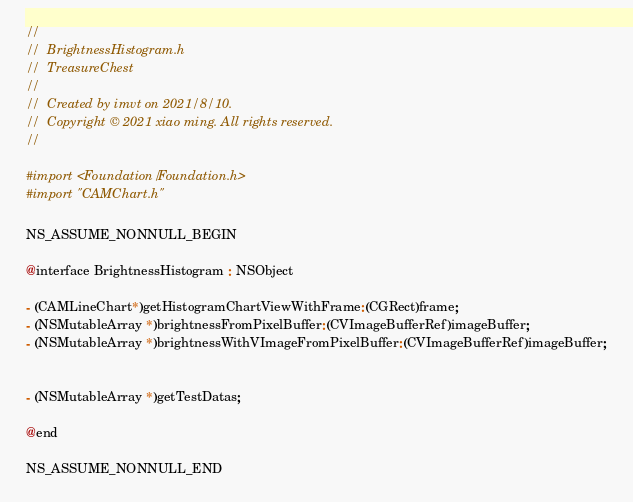<code> <loc_0><loc_0><loc_500><loc_500><_C_>//
//  BrightnessHistogram.h
//  TreasureChest
//
//  Created by imvt on 2021/8/10.
//  Copyright © 2021 xiao ming. All rights reserved.
//

#import <Foundation/Foundation.h>
#import "CAMChart.h"

NS_ASSUME_NONNULL_BEGIN

@interface BrightnessHistogram : NSObject

- (CAMLineChart*)getHistogramChartViewWithFrame:(CGRect)frame;
- (NSMutableArray *)brightnessFromPixelBuffer:(CVImageBufferRef)imageBuffer;
- (NSMutableArray *)brightnessWithVImageFromPixelBuffer:(CVImageBufferRef)imageBuffer;


- (NSMutableArray *)getTestDatas;

@end

NS_ASSUME_NONNULL_END
</code> 